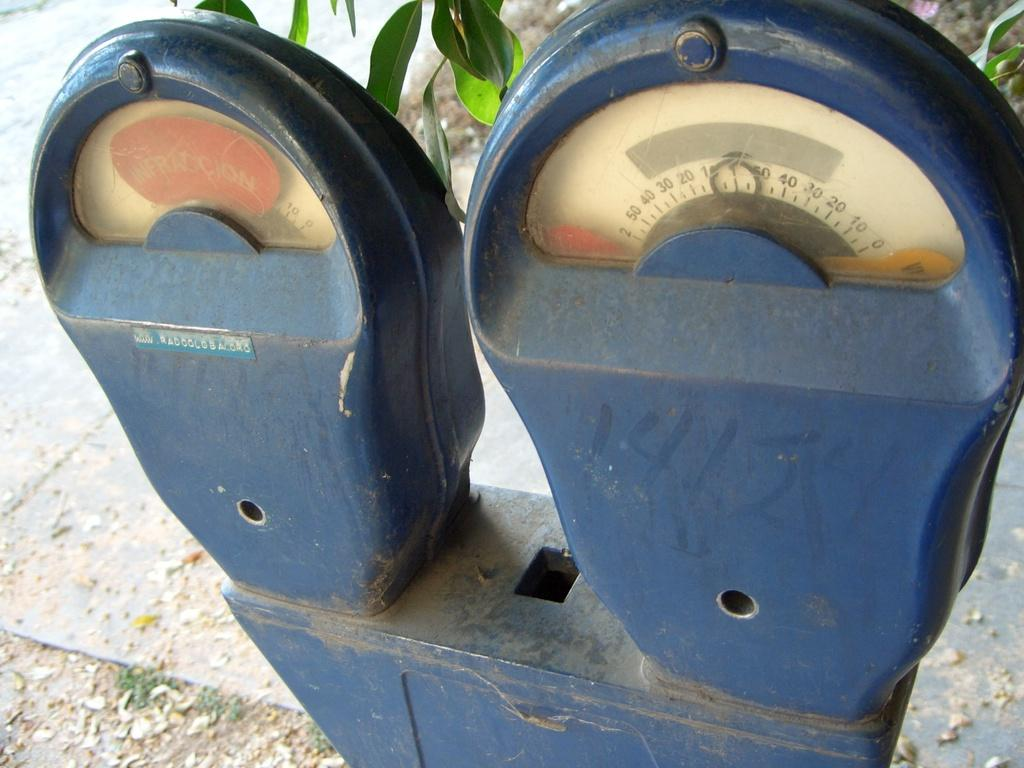Provide a one-sentence caption for the provided image. The parking meter is on red and states infraccion. 